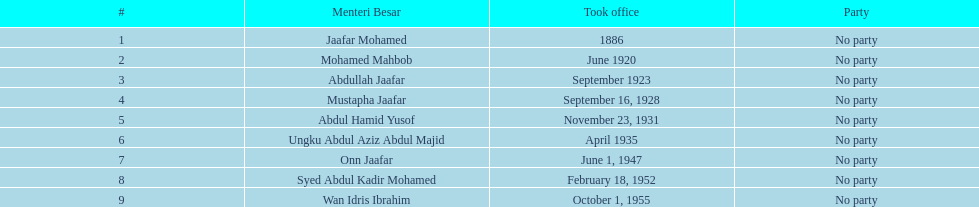Who succeeded abdullah jaafar in office? Mustapha Jaafar. 